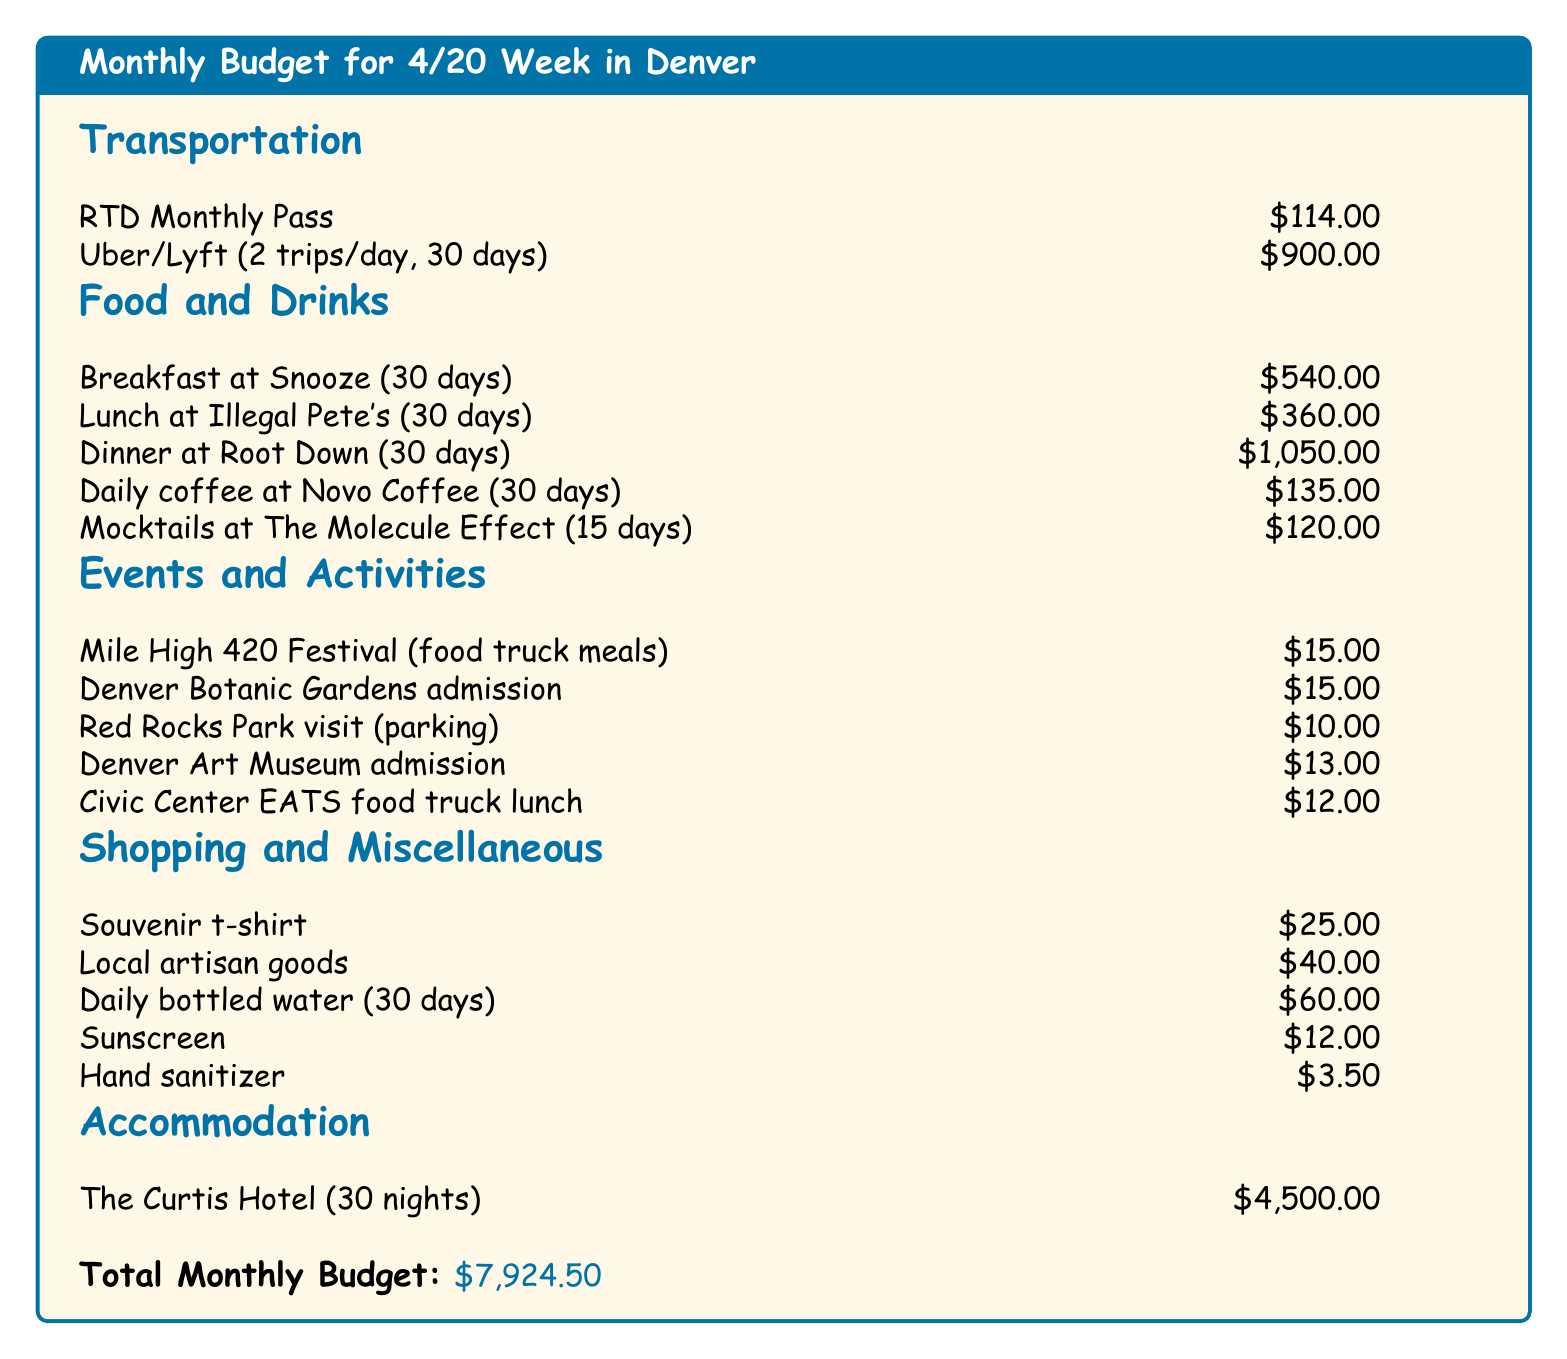What is the cost of the RTD Monthly Pass? The document lists the RTD Monthly Pass as a transportation expense totaling $114.00.
Answer: $114.00 How much is spent on dinner at Root Down for 30 days? The budget shows that dinner at Root Down costs $1,050.00 for 30 days.
Answer: $1,050.00 What is the total amount allocated for food and drinks? The total amount for food and drinks can be calculated by adding all individual food costs, which sum up to $2,085.00.
Answer: $2,085.00 What is the cost associated with accommodating at The Curtis Hotel for one month? The document specifies lodging costs at The Curtis Hotel for 30 nights as $4,500.00.
Answer: $4,500.00 What is the total monthly budget? The document concludes that the total monthly budget for Denver during 4/20 week is $7,924.50.
Answer: $7,924.50 How much is budgeted for local artisan goods? Local artisan goods are budgeted at $40.00, as mentioned in the shopping and miscellaneous section.
Answer: $40.00 How many mocktails are included in the budget? The budget accounts for mocktails at The Molecule Effect for 15 days, which is indicated in the food and drinks section.
Answer: 15 days What is the parking cost for visiting Red Rocks Park? The document states that parking at Red Rocks Park costs $10.00.
Answer: $10.00 What is the total amount spent on transportation? The total transportation costs can be calculated by adding the RTD Monthly Pass ($114.00) and Uber/Lyft expenses ($900.00) for a total of $1,014.00.
Answer: $1,014.00 